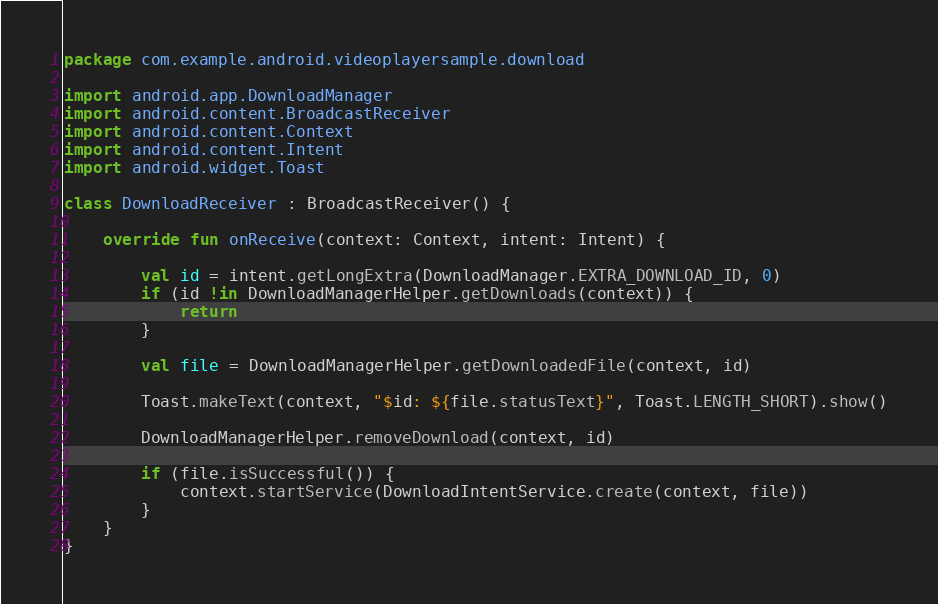<code> <loc_0><loc_0><loc_500><loc_500><_Kotlin_>package com.example.android.videoplayersample.download

import android.app.DownloadManager
import android.content.BroadcastReceiver
import android.content.Context
import android.content.Intent
import android.widget.Toast

class DownloadReceiver : BroadcastReceiver() {

    override fun onReceive(context: Context, intent: Intent) {

        val id = intent.getLongExtra(DownloadManager.EXTRA_DOWNLOAD_ID, 0)
        if (id !in DownloadManagerHelper.getDownloads(context)) {
            return
        }

        val file = DownloadManagerHelper.getDownloadedFile(context, id)

        Toast.makeText(context, "$id: ${file.statusText}", Toast.LENGTH_SHORT).show()

        DownloadManagerHelper.removeDownload(context, id)

        if (file.isSuccessful()) {
            context.startService(DownloadIntentService.create(context, file))
        }
    }
}
</code> 